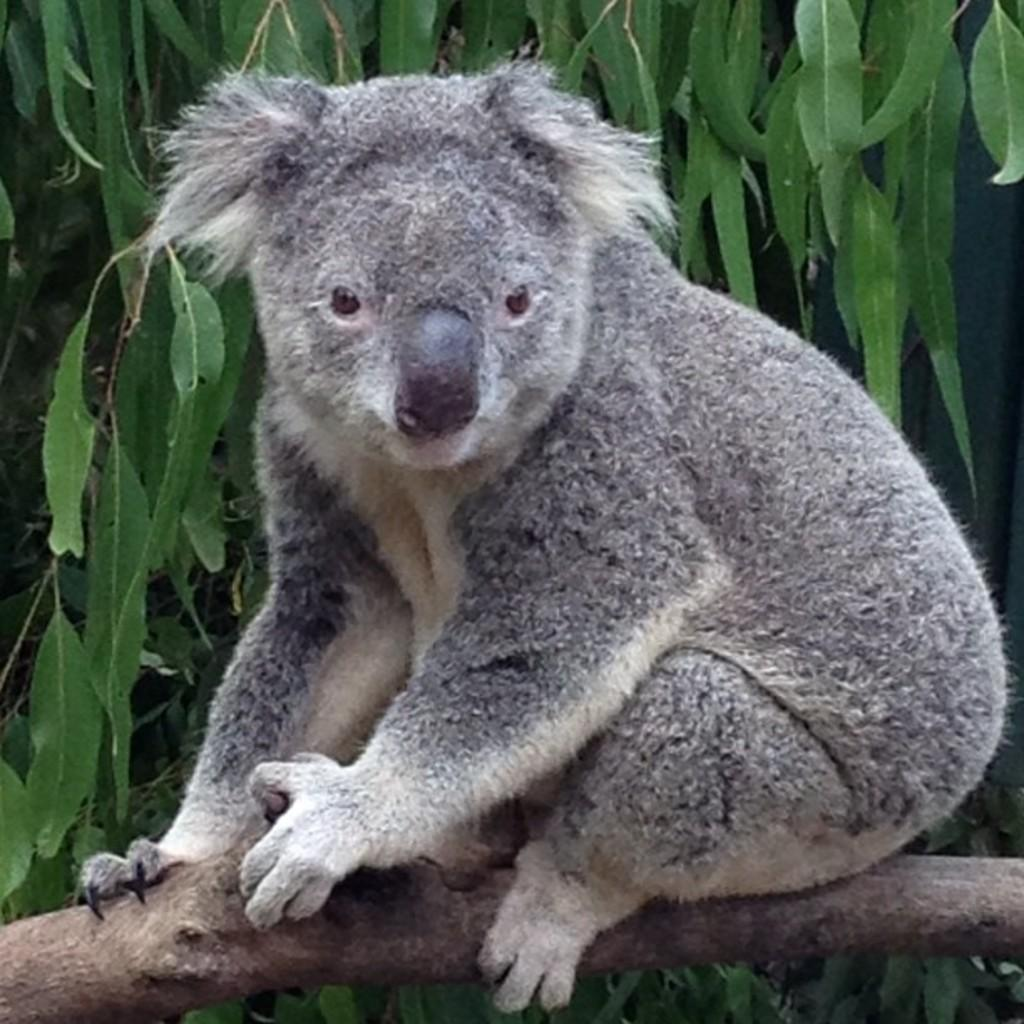What animal is in the image? There is a koala in the image. Where is the koala located? The koala is on a log. What can be seen behind the koala? There is a tree behind the koala. What position does the koala hold in the image? The koala is not holding a position in the image; it is simply sitting on a log. Can the koala reach into its pocket in the image? There are no pockets visible on the koala in the image, and koalas do not have pockets in real life. 